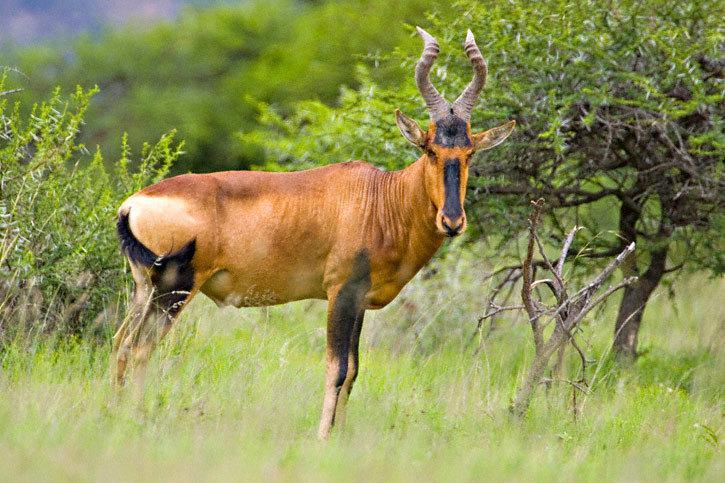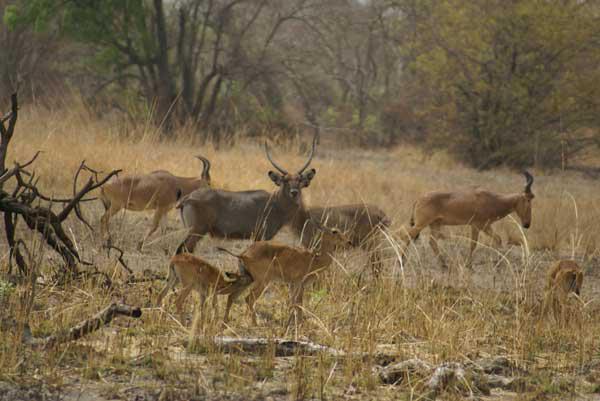The first image is the image on the left, the second image is the image on the right. For the images displayed, is the sentence "Left image contains one horned animal, which is eyeing the camera, with its body turned rightward." factually correct? Answer yes or no. Yes. The first image is the image on the left, the second image is the image on the right. Assess this claim about the two images: "There are four ruminant animals (antelope types).". Correct or not? Answer yes or no. No. 